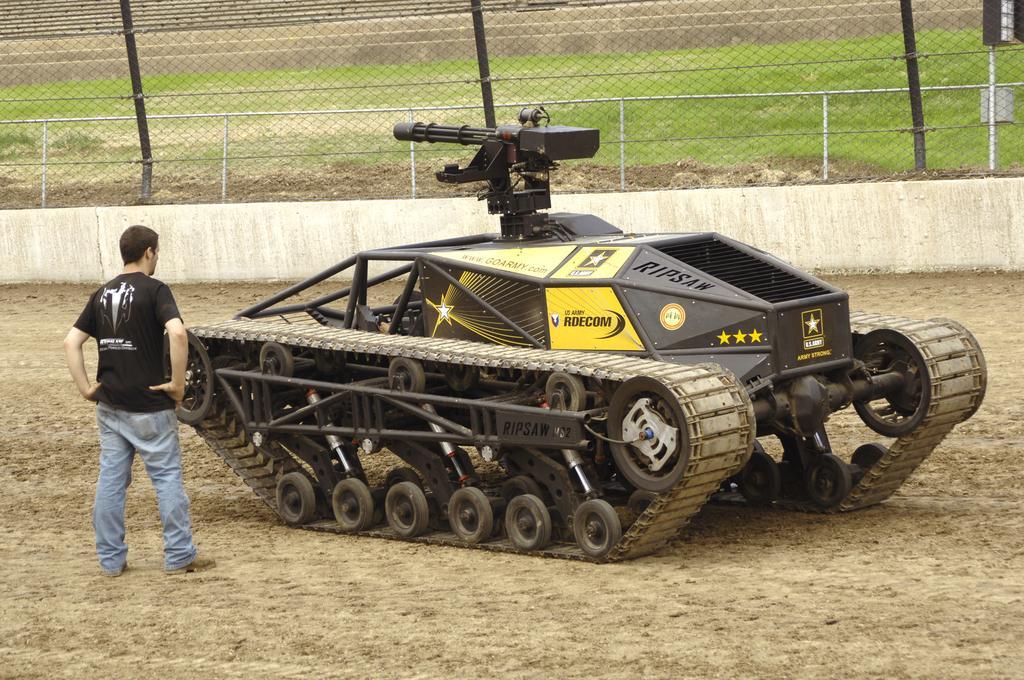In one or two sentences, can you explain what this image depicts? In this image I can see a tanker, person on the ground, fence, grass and net. This image is taken may be on the ground. 